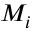Convert formula to latex. <formula><loc_0><loc_0><loc_500><loc_500>M _ { i }</formula> 